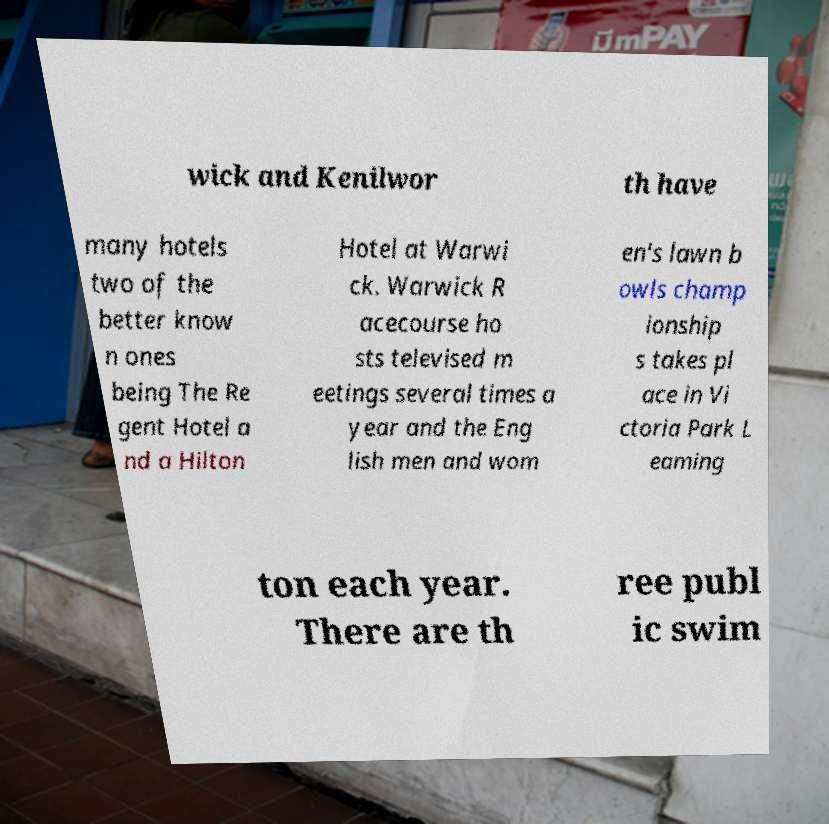Could you extract and type out the text from this image? wick and Kenilwor th have many hotels two of the better know n ones being The Re gent Hotel a nd a Hilton Hotel at Warwi ck. Warwick R acecourse ho sts televised m eetings several times a year and the Eng lish men and wom en's lawn b owls champ ionship s takes pl ace in Vi ctoria Park L eaming ton each year. There are th ree publ ic swim 